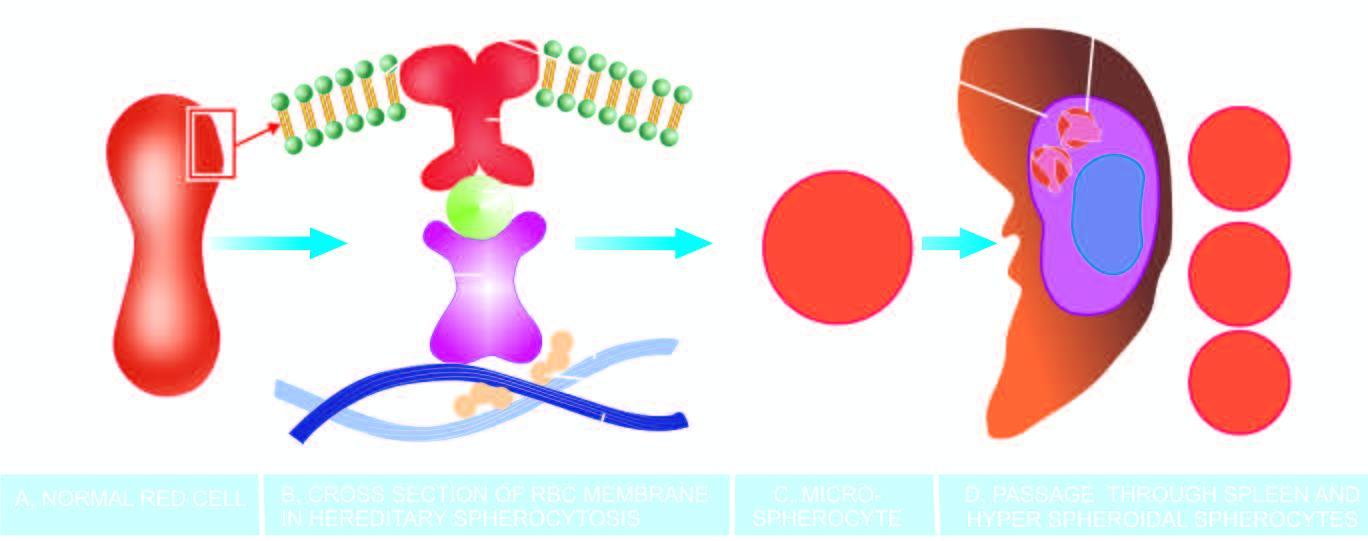does this result in spherical contour and small size so as to contain the given volume of haemoglobin in the deformed red cell?
Answer the question using a single word or phrase. Yes 